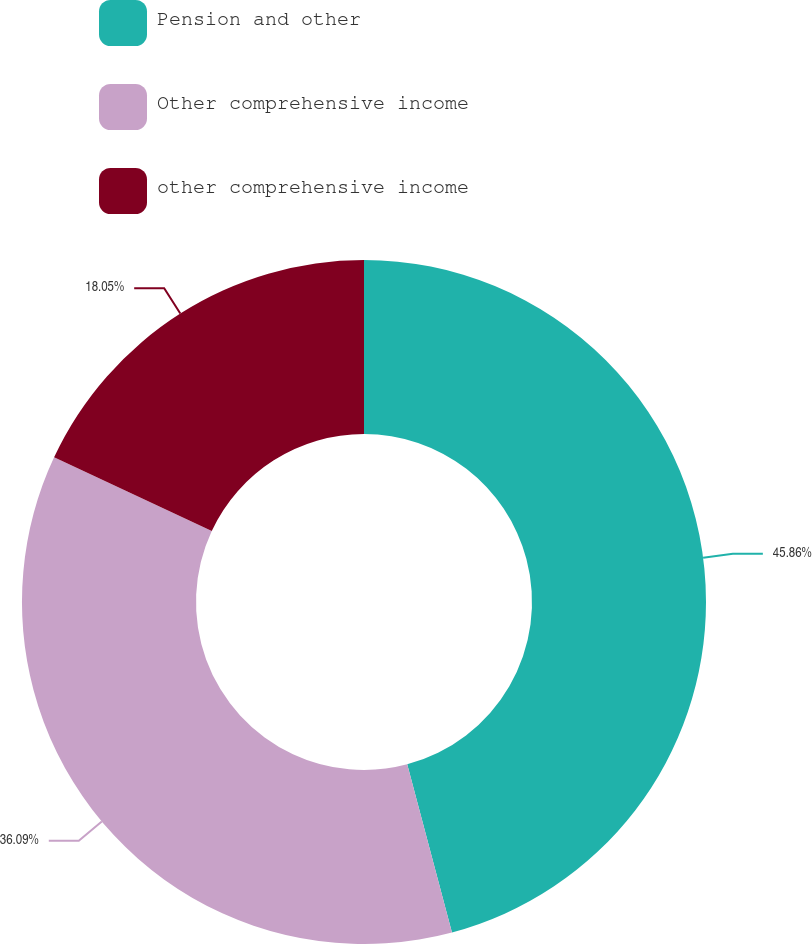<chart> <loc_0><loc_0><loc_500><loc_500><pie_chart><fcel>Pension and other<fcel>Other comprehensive income<fcel>other comprehensive income<nl><fcel>45.86%<fcel>36.09%<fcel>18.05%<nl></chart> 